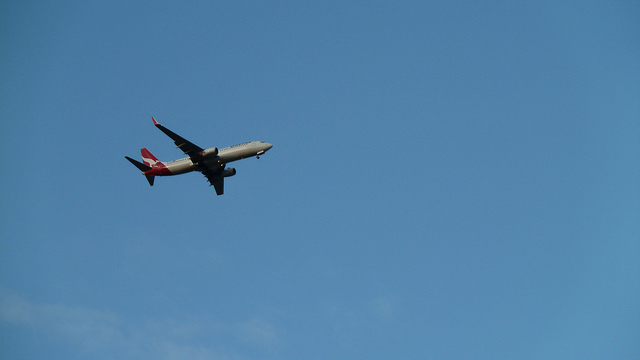<image>Is the plane landing? It is unclear if the plane is landing. Is the plane landing? I don't know if the plane is landing. It can be seen that it is not landing based on the annotations. 